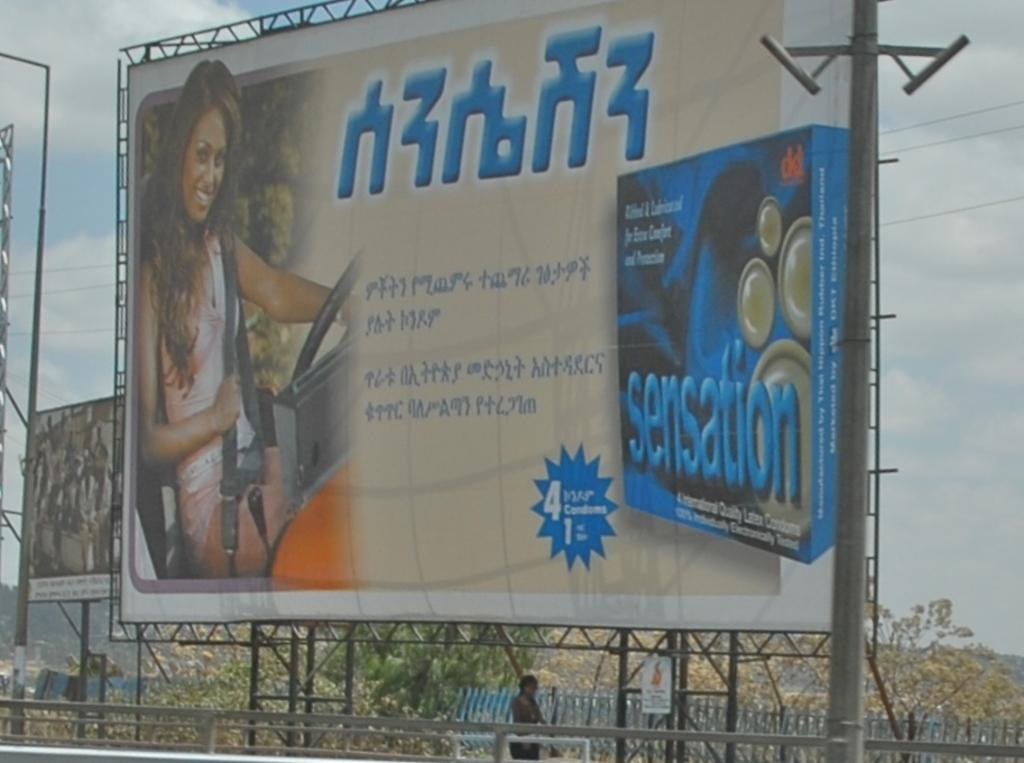Provide a one-sentence caption for the provided image. The product shown here gives you a great sensation if you take it. 